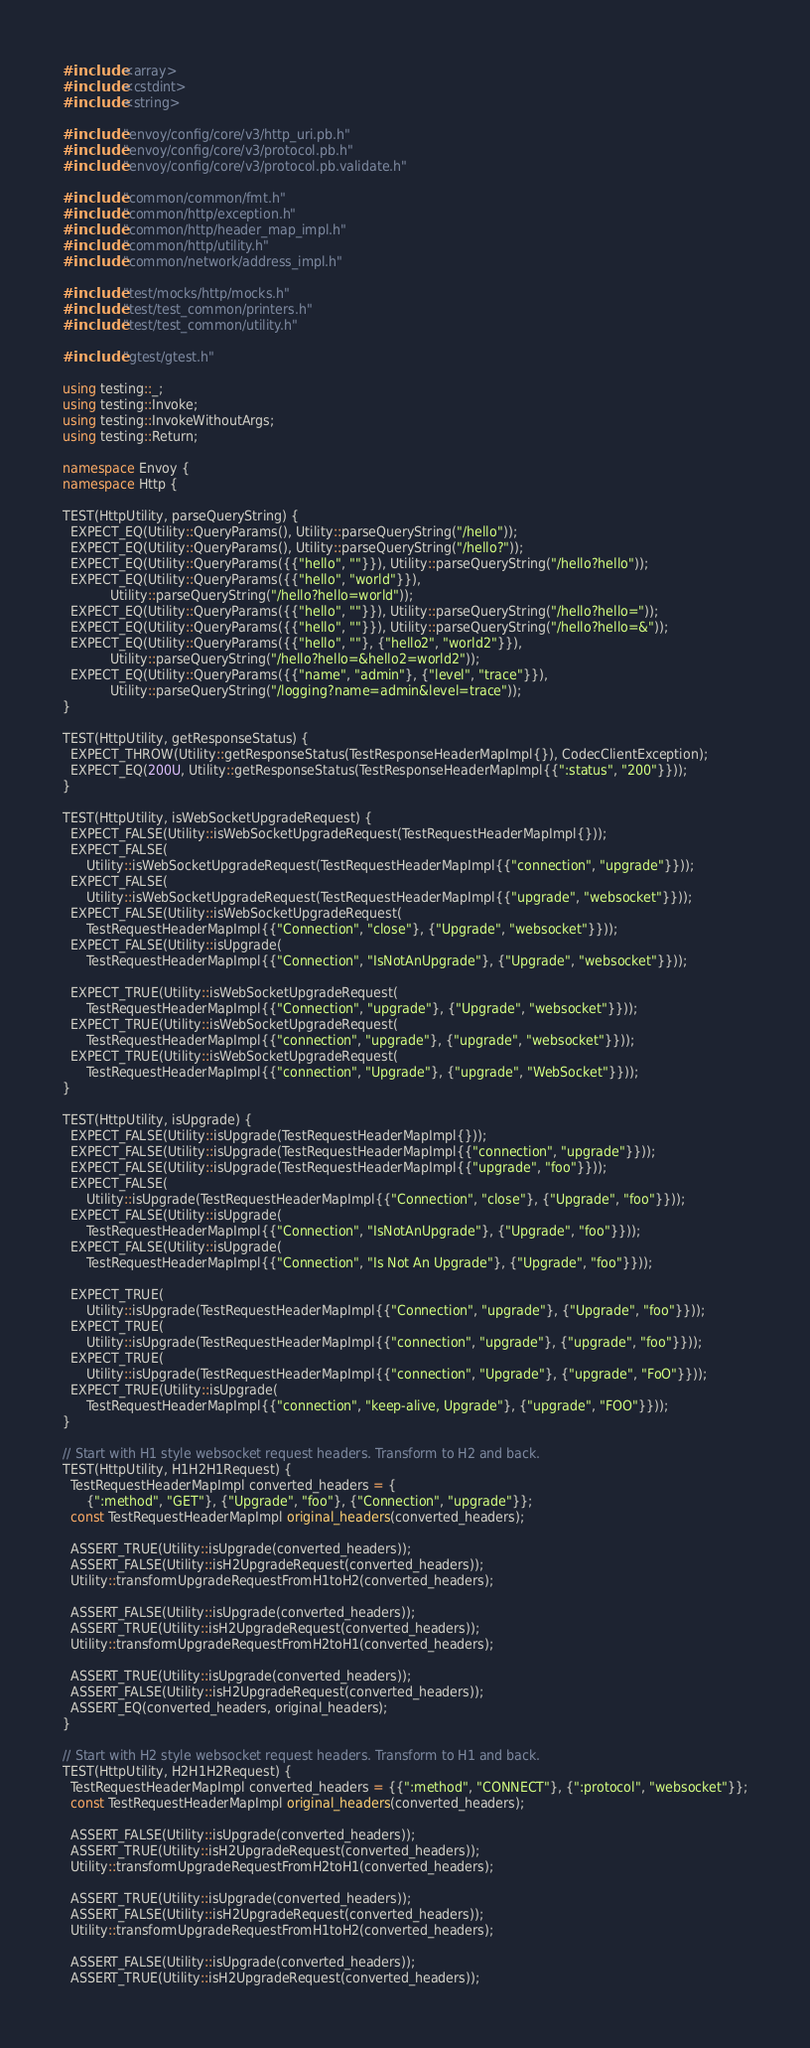<code> <loc_0><loc_0><loc_500><loc_500><_C++_>#include <array>
#include <cstdint>
#include <string>

#include "envoy/config/core/v3/http_uri.pb.h"
#include "envoy/config/core/v3/protocol.pb.h"
#include "envoy/config/core/v3/protocol.pb.validate.h"

#include "common/common/fmt.h"
#include "common/http/exception.h"
#include "common/http/header_map_impl.h"
#include "common/http/utility.h"
#include "common/network/address_impl.h"

#include "test/mocks/http/mocks.h"
#include "test/test_common/printers.h"
#include "test/test_common/utility.h"

#include "gtest/gtest.h"

using testing::_;
using testing::Invoke;
using testing::InvokeWithoutArgs;
using testing::Return;

namespace Envoy {
namespace Http {

TEST(HttpUtility, parseQueryString) {
  EXPECT_EQ(Utility::QueryParams(), Utility::parseQueryString("/hello"));
  EXPECT_EQ(Utility::QueryParams(), Utility::parseQueryString("/hello?"));
  EXPECT_EQ(Utility::QueryParams({{"hello", ""}}), Utility::parseQueryString("/hello?hello"));
  EXPECT_EQ(Utility::QueryParams({{"hello", "world"}}),
            Utility::parseQueryString("/hello?hello=world"));
  EXPECT_EQ(Utility::QueryParams({{"hello", ""}}), Utility::parseQueryString("/hello?hello="));
  EXPECT_EQ(Utility::QueryParams({{"hello", ""}}), Utility::parseQueryString("/hello?hello=&"));
  EXPECT_EQ(Utility::QueryParams({{"hello", ""}, {"hello2", "world2"}}),
            Utility::parseQueryString("/hello?hello=&hello2=world2"));
  EXPECT_EQ(Utility::QueryParams({{"name", "admin"}, {"level", "trace"}}),
            Utility::parseQueryString("/logging?name=admin&level=trace"));
}

TEST(HttpUtility, getResponseStatus) {
  EXPECT_THROW(Utility::getResponseStatus(TestResponseHeaderMapImpl{}), CodecClientException);
  EXPECT_EQ(200U, Utility::getResponseStatus(TestResponseHeaderMapImpl{{":status", "200"}}));
}

TEST(HttpUtility, isWebSocketUpgradeRequest) {
  EXPECT_FALSE(Utility::isWebSocketUpgradeRequest(TestRequestHeaderMapImpl{}));
  EXPECT_FALSE(
      Utility::isWebSocketUpgradeRequest(TestRequestHeaderMapImpl{{"connection", "upgrade"}}));
  EXPECT_FALSE(
      Utility::isWebSocketUpgradeRequest(TestRequestHeaderMapImpl{{"upgrade", "websocket"}}));
  EXPECT_FALSE(Utility::isWebSocketUpgradeRequest(
      TestRequestHeaderMapImpl{{"Connection", "close"}, {"Upgrade", "websocket"}}));
  EXPECT_FALSE(Utility::isUpgrade(
      TestRequestHeaderMapImpl{{"Connection", "IsNotAnUpgrade"}, {"Upgrade", "websocket"}}));

  EXPECT_TRUE(Utility::isWebSocketUpgradeRequest(
      TestRequestHeaderMapImpl{{"Connection", "upgrade"}, {"Upgrade", "websocket"}}));
  EXPECT_TRUE(Utility::isWebSocketUpgradeRequest(
      TestRequestHeaderMapImpl{{"connection", "upgrade"}, {"upgrade", "websocket"}}));
  EXPECT_TRUE(Utility::isWebSocketUpgradeRequest(
      TestRequestHeaderMapImpl{{"connection", "Upgrade"}, {"upgrade", "WebSocket"}}));
}

TEST(HttpUtility, isUpgrade) {
  EXPECT_FALSE(Utility::isUpgrade(TestRequestHeaderMapImpl{}));
  EXPECT_FALSE(Utility::isUpgrade(TestRequestHeaderMapImpl{{"connection", "upgrade"}}));
  EXPECT_FALSE(Utility::isUpgrade(TestRequestHeaderMapImpl{{"upgrade", "foo"}}));
  EXPECT_FALSE(
      Utility::isUpgrade(TestRequestHeaderMapImpl{{"Connection", "close"}, {"Upgrade", "foo"}}));
  EXPECT_FALSE(Utility::isUpgrade(
      TestRequestHeaderMapImpl{{"Connection", "IsNotAnUpgrade"}, {"Upgrade", "foo"}}));
  EXPECT_FALSE(Utility::isUpgrade(
      TestRequestHeaderMapImpl{{"Connection", "Is Not An Upgrade"}, {"Upgrade", "foo"}}));

  EXPECT_TRUE(
      Utility::isUpgrade(TestRequestHeaderMapImpl{{"Connection", "upgrade"}, {"Upgrade", "foo"}}));
  EXPECT_TRUE(
      Utility::isUpgrade(TestRequestHeaderMapImpl{{"connection", "upgrade"}, {"upgrade", "foo"}}));
  EXPECT_TRUE(
      Utility::isUpgrade(TestRequestHeaderMapImpl{{"connection", "Upgrade"}, {"upgrade", "FoO"}}));
  EXPECT_TRUE(Utility::isUpgrade(
      TestRequestHeaderMapImpl{{"connection", "keep-alive, Upgrade"}, {"upgrade", "FOO"}}));
}

// Start with H1 style websocket request headers. Transform to H2 and back.
TEST(HttpUtility, H1H2H1Request) {
  TestRequestHeaderMapImpl converted_headers = {
      {":method", "GET"}, {"Upgrade", "foo"}, {"Connection", "upgrade"}};
  const TestRequestHeaderMapImpl original_headers(converted_headers);

  ASSERT_TRUE(Utility::isUpgrade(converted_headers));
  ASSERT_FALSE(Utility::isH2UpgradeRequest(converted_headers));
  Utility::transformUpgradeRequestFromH1toH2(converted_headers);

  ASSERT_FALSE(Utility::isUpgrade(converted_headers));
  ASSERT_TRUE(Utility::isH2UpgradeRequest(converted_headers));
  Utility::transformUpgradeRequestFromH2toH1(converted_headers);

  ASSERT_TRUE(Utility::isUpgrade(converted_headers));
  ASSERT_FALSE(Utility::isH2UpgradeRequest(converted_headers));
  ASSERT_EQ(converted_headers, original_headers);
}

// Start with H2 style websocket request headers. Transform to H1 and back.
TEST(HttpUtility, H2H1H2Request) {
  TestRequestHeaderMapImpl converted_headers = {{":method", "CONNECT"}, {":protocol", "websocket"}};
  const TestRequestHeaderMapImpl original_headers(converted_headers);

  ASSERT_FALSE(Utility::isUpgrade(converted_headers));
  ASSERT_TRUE(Utility::isH2UpgradeRequest(converted_headers));
  Utility::transformUpgradeRequestFromH2toH1(converted_headers);

  ASSERT_TRUE(Utility::isUpgrade(converted_headers));
  ASSERT_FALSE(Utility::isH2UpgradeRequest(converted_headers));
  Utility::transformUpgradeRequestFromH1toH2(converted_headers);

  ASSERT_FALSE(Utility::isUpgrade(converted_headers));
  ASSERT_TRUE(Utility::isH2UpgradeRequest(converted_headers));</code> 